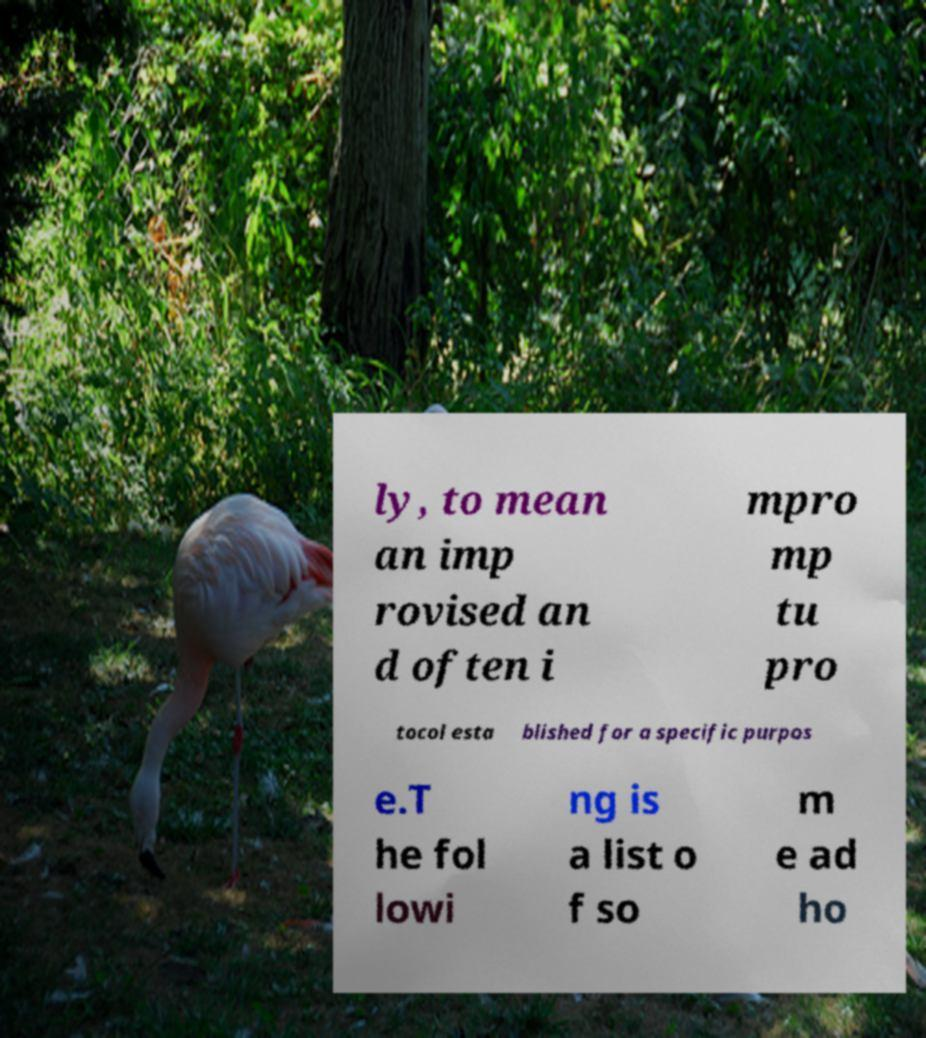What messages or text are displayed in this image? I need them in a readable, typed format. ly, to mean an imp rovised an d often i mpro mp tu pro tocol esta blished for a specific purpos e.T he fol lowi ng is a list o f so m e ad ho 